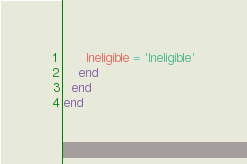<code> <loc_0><loc_0><loc_500><loc_500><_Ruby_>      Ineligible = 'Ineligible'
    end
  end
end

</code> 